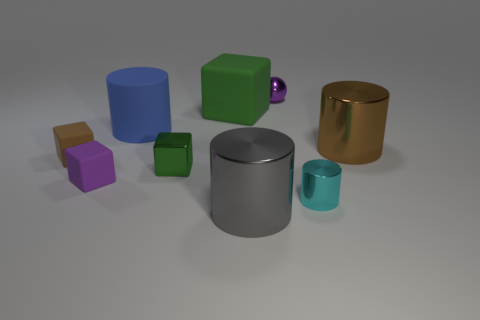Add 1 small blue blocks. How many objects exist? 10 Subtract all balls. How many objects are left? 8 Subtract 1 gray cylinders. How many objects are left? 8 Subtract all tiny brown metallic blocks. Subtract all gray things. How many objects are left? 8 Add 7 brown metallic cylinders. How many brown metallic cylinders are left? 8 Add 8 big brown spheres. How many big brown spheres exist? 8 